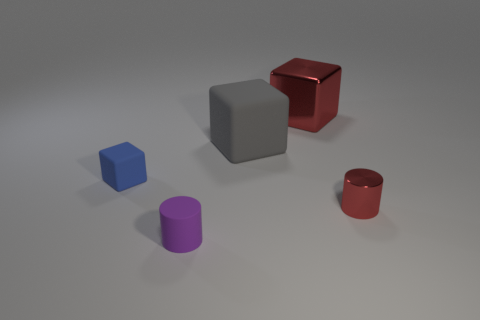There is a tiny object that is the same color as the metallic cube; what is its material?
Offer a very short reply. Metal. Are there the same number of large objects behind the large red cube and red shiny balls?
Keep it short and to the point. Yes. There is a tiny matte block; are there any small blocks behind it?
Keep it short and to the point. No. Does the tiny red shiny thing have the same shape as the object on the left side of the matte cylinder?
Provide a short and direct response. No. The other block that is the same material as the tiny blue block is what color?
Ensure brevity in your answer.  Gray. The metallic block is what color?
Offer a terse response. Red. Is the material of the small block the same as the small cylinder that is right of the big matte cube?
Ensure brevity in your answer.  No. How many objects are behind the tiny red metallic object and in front of the big red shiny cube?
Offer a terse response. 2. There is a matte thing that is the same size as the red metallic block; what is its shape?
Provide a short and direct response. Cube. Is there a small red object that is right of the metal thing behind the tiny thing that is to the right of the big gray matte cube?
Offer a terse response. Yes. 